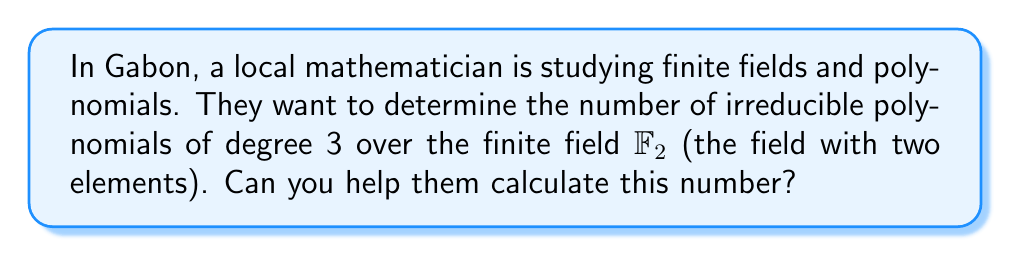Give your solution to this math problem. Let's approach this step-by-step:

1) First, recall the formula for the number of irreducible polynomials of degree $n$ over a finite field $\mathbb{F}_q$:

   $$N_n = \frac{1}{n} \sum_{d|n} \mu(d)q^{n/d}$$

   where $\mu(d)$ is the Möbius function.

2) In this case, $n = 3$ and $q = 2$ (since we're working over $\mathbb{F}_2$).

3) The divisors of 3 are 1 and 3. So our sum will have two terms:

   $$N_3 = \frac{1}{3} [\mu(1)2^{3/1} + \mu(3)2^{3/3}]$$

4) Now, let's calculate the Möbius function values:
   $\mu(1) = 1$
   $\mu(3) = -1$ (since 3 is prime)

5) Substituting these values:

   $$N_3 = \frac{1}{3} [1 \cdot 2^3 + (-1) \cdot 2^1]$$

6) Simplify:
   $$N_3 = \frac{1}{3} [8 - 2] = \frac{1}{3} [6] = 2$$

Therefore, there are 2 irreducible polynomials of degree 3 over $\mathbb{F}_2$.
Answer: 2 